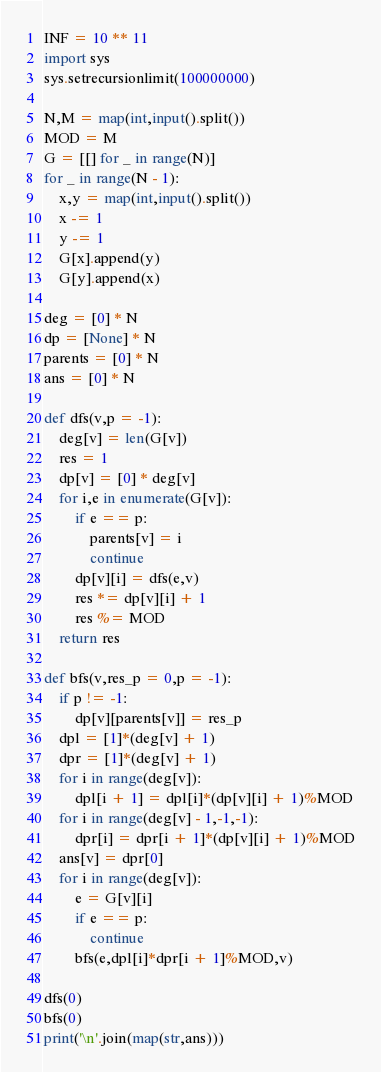<code> <loc_0><loc_0><loc_500><loc_500><_Python_>INF = 10 ** 11
import sys
sys.setrecursionlimit(100000000)

N,M = map(int,input().split())
MOD = M
G = [[] for _ in range(N)]
for _ in range(N - 1):
    x,y = map(int,input().split())
    x -= 1
    y -= 1
    G[x].append(y)
    G[y].append(x)

deg = [0] * N
dp = [None] * N
parents = [0] * N
ans = [0] * N

def dfs(v,p = -1):
    deg[v] = len(G[v])
    res = 1
    dp[v] = [0] * deg[v]
    for i,e in enumerate(G[v]):
        if e == p:
            parents[v] = i
            continue
        dp[v][i] = dfs(e,v)
        res *= dp[v][i] + 1
        res %= MOD
    return res

def bfs(v,res_p = 0,p = -1):
    if p != -1:
        dp[v][parents[v]] = res_p
    dpl = [1]*(deg[v] + 1)
    dpr = [1]*(deg[v] + 1)
    for i in range(deg[v]):
        dpl[i + 1] = dpl[i]*(dp[v][i] + 1)%MOD
    for i in range(deg[v] - 1,-1,-1):
        dpr[i] = dpr[i + 1]*(dp[v][i] + 1)%MOD
    ans[v] = dpr[0]
    for i in range(deg[v]):
        e = G[v][i]
        if e == p:
            continue
        bfs(e,dpl[i]*dpr[i + 1]%MOD,v)

dfs(0)
bfs(0)
print('\n'.join(map(str,ans)))</code> 